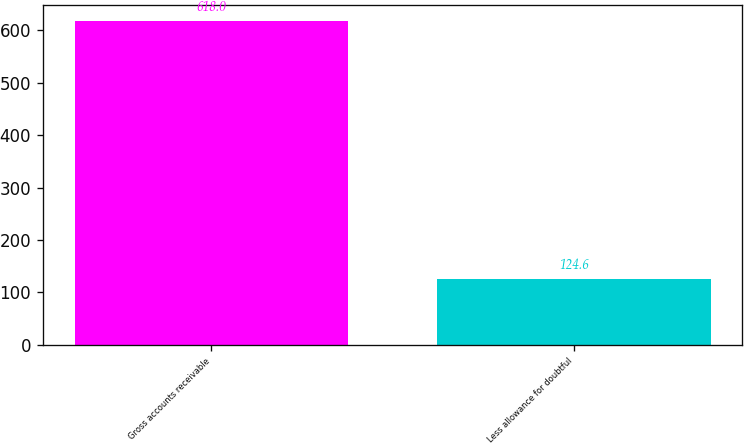Convert chart to OTSL. <chart><loc_0><loc_0><loc_500><loc_500><bar_chart><fcel>Gross accounts receivable<fcel>Less allowance for doubtful<nl><fcel>618<fcel>124.6<nl></chart> 